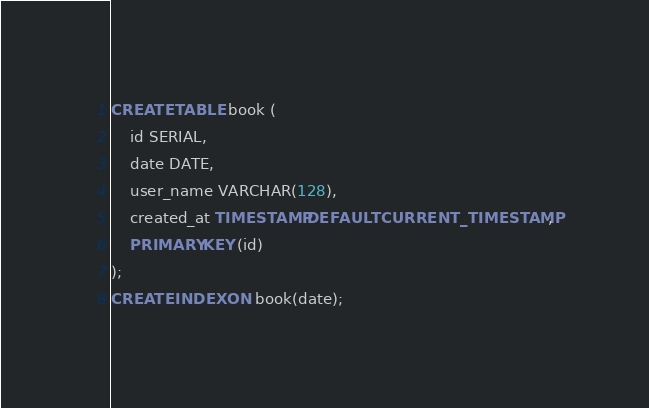<code> <loc_0><loc_0><loc_500><loc_500><_SQL_>CREATE TABLE book (
	id SERIAL,
	date DATE,
	user_name VARCHAR(128),
	created_at TIMESTAMP DEFAULT CURRENT_TIMESTAMP,
	PRIMARY KEY (id)
);
CREATE INDEX ON book(date);
</code> 